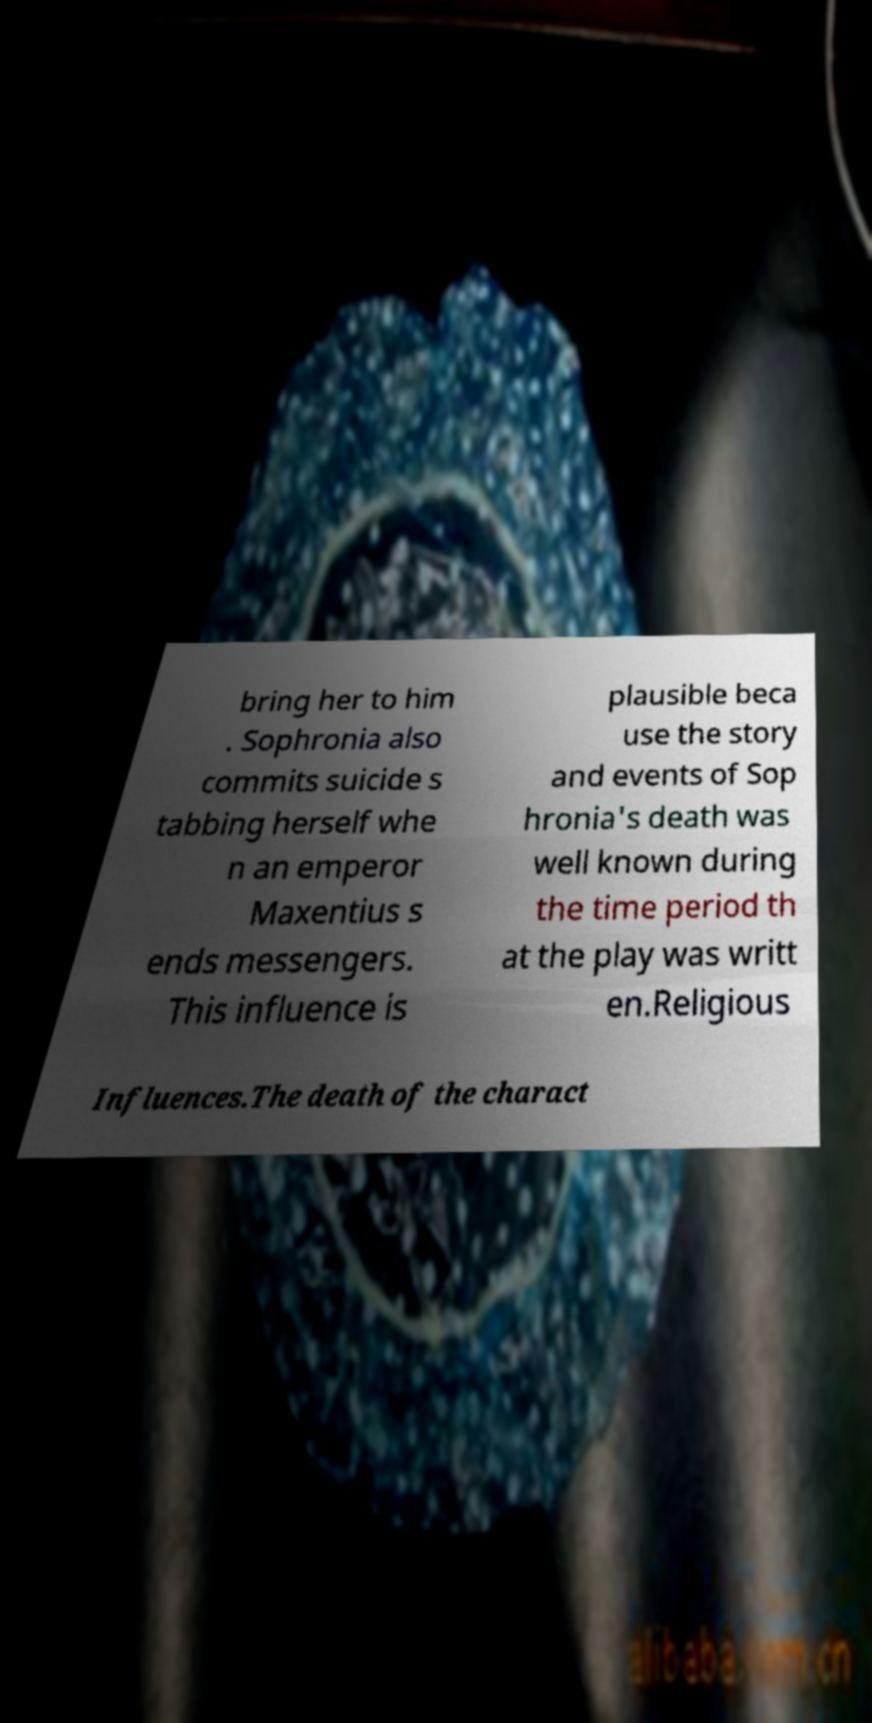Please identify and transcribe the text found in this image. bring her to him . Sophronia also commits suicide s tabbing herself whe n an emperor Maxentius s ends messengers. This influence is plausible beca use the story and events of Sop hronia's death was well known during the time period th at the play was writt en.Religious Influences.The death of the charact 